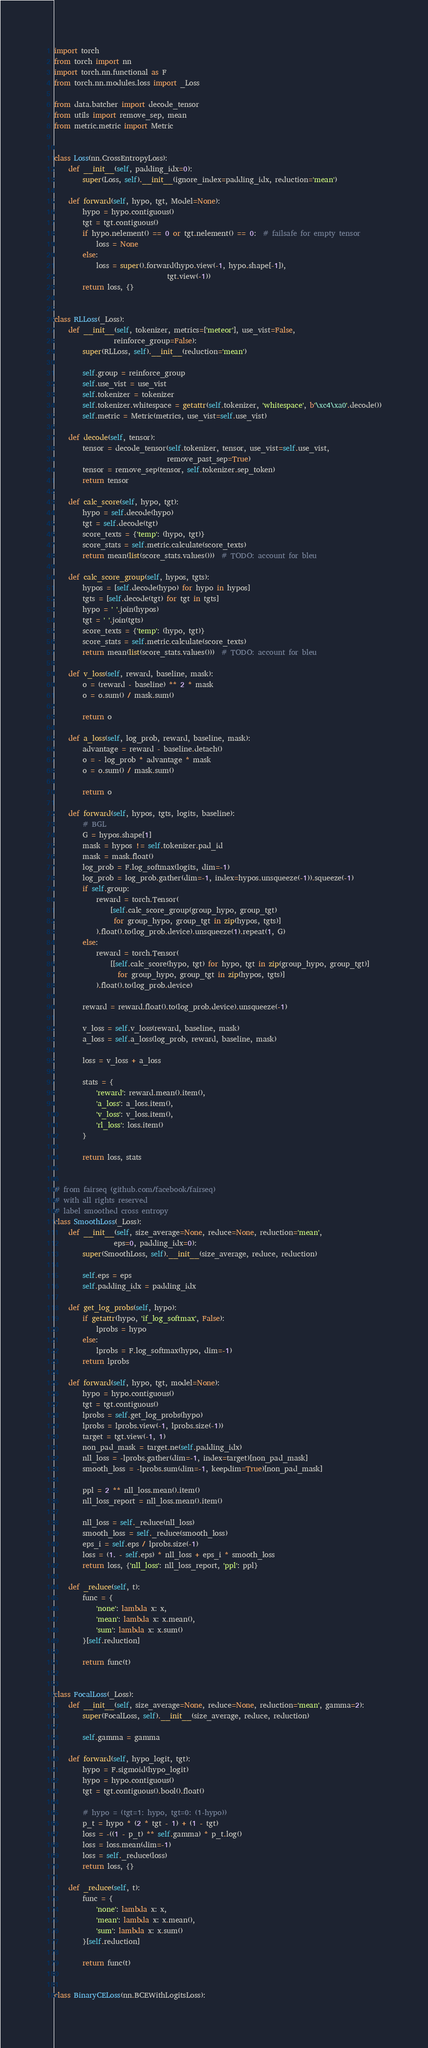<code> <loc_0><loc_0><loc_500><loc_500><_Python_>import torch
from torch import nn
import torch.nn.functional as F
from torch.nn.modules.loss import _Loss

from data.batcher import decode_tensor
from utils import remove_sep, mean
from metric.metric import Metric


class Loss(nn.CrossEntropyLoss):
    def __init__(self, padding_idx=0):
        super(Loss, self).__init__(ignore_index=padding_idx, reduction='mean')

    def forward(self, hypo, tgt, Model=None):
        hypo = hypo.contiguous()
        tgt = tgt.contiguous()
        if hypo.nelement() == 0 or tgt.nelement() == 0:  # failsafe for empty tensor
            loss = None
        else:
            loss = super().forward(hypo.view(-1, hypo.shape[-1]),
                                tgt.view(-1))
        return loss, {}


class RLLoss(_Loss):
    def __init__(self, tokenizer, metrics=['meteor'], use_vist=False,
                 reinforce_group=False):
        super(RLLoss, self).__init__(reduction='mean')

        self.group = reinforce_group
        self.use_vist = use_vist
        self.tokenizer = tokenizer
        self.tokenizer.whitespace = getattr(self.tokenizer, 'whitespace', b'\xc4\xa0'.decode())
        self.metric = Metric(metrics, use_vist=self.use_vist)

    def decode(self, tensor):
        tensor = decode_tensor(self.tokenizer, tensor, use_vist=self.use_vist,
                                remove_past_sep=True)
        tensor = remove_sep(tensor, self.tokenizer.sep_token)
        return tensor

    def calc_score(self, hypo, tgt):
        hypo = self.decode(hypo)
        tgt = self.decode(tgt)
        score_texts = {'temp': (hypo, tgt)}
        score_stats = self.metric.calculate(score_texts)
        return mean(list(score_stats.values()))  # TODO: account for bleu

    def calc_score_group(self, hypos, tgts):
        hypos = [self.decode(hypo) for hypo in hypos]
        tgts = [self.decode(tgt) for tgt in tgts]
        hypo = ' '.join(hypos)
        tgt = ' '.join(tgts)
        score_texts = {'temp': (hypo, tgt)}
        score_stats = self.metric.calculate(score_texts)
        return mean(list(score_stats.values()))  # TODO: account for bleu

    def v_loss(self, reward, baseline, mask):
        o = (reward - baseline) ** 2 * mask
        o = o.sum() / mask.sum()

        return o

    def a_loss(self, log_prob, reward, baseline, mask):
        advantage = reward - baseline.detach()
        o = - log_prob * advantage * mask
        o = o.sum() / mask.sum()

        return o

    def forward(self, hypos, tgts, logits, baseline):
        # BGL
        G = hypos.shape[1]
        mask = hypos != self.tokenizer.pad_id
        mask = mask.float()
        log_prob = F.log_softmax(logits, dim=-1)
        log_prob = log_prob.gather(dim=-1, index=hypos.unsqueeze(-1)).squeeze(-1)
        if self.group:
            reward = torch.Tensor(
                [self.calc_score_group(group_hypo, group_tgt)
                 for group_hypo, group_tgt in zip(hypos, tgts)]
            ).float().to(log_prob.device).unsqueeze(1).repeat(1, G)
        else:
            reward = torch.Tensor(
                [[self.calc_score(hypo, tgt) for hypo, tgt in zip(group_hypo, group_tgt)]
                  for group_hypo, group_tgt in zip(hypos, tgts)]
            ).float().to(log_prob.device)

        reward = reward.float().to(log_prob.device).unsqueeze(-1)

        v_loss = self.v_loss(reward, baseline, mask)
        a_loss = self.a_loss(log_prob, reward, baseline, mask)

        loss = v_loss + a_loss

        stats = {
            'reward': reward.mean().item(),
            'a_loss': a_loss.item(),
            'v_loss': v_loss.item(),
            'rl_loss': loss.item()
        }

        return loss, stats


# from fairseq (github.com/facebook/fairseq)
# with all rights reserved
# label smoothed cross entropy
class SmoothLoss(_Loss):
    def __init__(self, size_average=None, reduce=None, reduction='mean',
                 eps=0, padding_idx=0):
        super(SmoothLoss, self).__init__(size_average, reduce, reduction)

        self.eps = eps
        self.padding_idx = padding_idx

    def get_log_probs(self, hypo):
        if getattr(hypo, 'if_log_softmax', False):
            lprobs = hypo
        else:
            lprobs = F.log_softmax(hypo, dim=-1)
        return lprobs

    def forward(self, hypo, tgt, model=None):
        hypo = hypo.contiguous()
        tgt = tgt.contiguous()
        lprobs = self.get_log_probs(hypo)
        lprobs = lprobs.view(-1, lprobs.size(-1))
        target = tgt.view(-1, 1)
        non_pad_mask = target.ne(self.padding_idx)
        nll_loss = -lprobs.gather(dim=-1, index=target)[non_pad_mask]
        smooth_loss = -lprobs.sum(dim=-1, keepdim=True)[non_pad_mask]

        ppl = 2 ** nll_loss.mean().item()
        nll_loss_report = nll_loss.mean().item()

        nll_loss = self._reduce(nll_loss)
        smooth_loss = self._reduce(smooth_loss)
        eps_i = self.eps / lprobs.size(-1)
        loss = (1. - self.eps) * nll_loss + eps_i * smooth_loss
        return loss, {'nll_loss': nll_loss_report, 'ppl': ppl}

    def _reduce(self, t):
        func = {
            'none': lambda x: x,
            'mean': lambda x: x.mean(),
            'sum': lambda x: x.sum()
        }[self.reduction]

        return func(t)


class FocalLoss(_Loss):
    def __init__(self, size_average=None, reduce=None, reduction='mean', gamma=2):
        super(FocalLoss, self).__init__(size_average, reduce, reduction)

        self.gamma = gamma

    def forward(self, hypo_logit, tgt):
        hypo = F.sigmoid(hypo_logit)
        hypo = hypo.contiguous()
        tgt = tgt.contiguous().bool().float()

        # hypo = (tgt=1: hypo, tgt=0: (1-hypo))
        p_t = hypo * (2 * tgt - 1) + (1 - tgt)
        loss = -((1 - p_t) ** self.gamma) * p_t.log()
        loss = loss.mean(dim=-1)
        loss = self._reduce(loss)
        return loss, {}

    def _reduce(self, t):
        func = {
            'none': lambda x: x,
            'mean': lambda x: x.mean(),
            'sum': lambda x: x.sum()
        }[self.reduction]

        return func(t)


class BinaryCELoss(nn.BCEWithLogitsLoss):</code> 